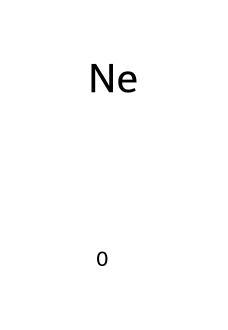What is the symbol for neon? The SMILES representation clearly indicates the element as "Ne", which is the chemical symbol for neon.
Answer: Ne How many neon atoms are in this chemical structure? The SMILES notation shows a single "Ne," indicating that there is one neon atom present.
Answer: 1 What kind of element is represented by this SMILES? The chemical structure consists of "Ne," which is recognized as a noble gas, an inert gas known for its lack of reactivity.
Answer: noble gas Does neon have any unpaired electrons? Neon has a complete outer shell of electrons (2 in the inner shell and 8 in the outer shell) hence it has no unpaired electrons.
Answer: no Why is neon used in signs? The inert nature of neon allows it to emit bright light when an electric current passes through it without reacting with other substances in the sign.
Answer: inert What is the electron configuration of neon? Neon has an atomic number of 10, which means its electron configuration is 1s² 2s² 2p⁶, filling its outer shell completely.
Answer: 1s² 2s² 2p⁶ 